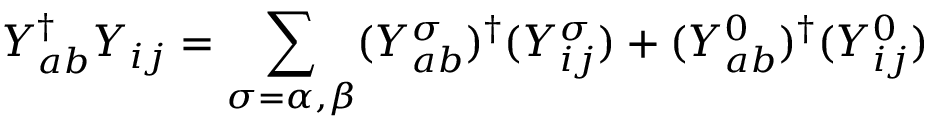Convert formula to latex. <formula><loc_0><loc_0><loc_500><loc_500>Y _ { a b } ^ { \dagger } Y _ { i j } = \sum _ { \sigma = \alpha , \beta } ( Y _ { a b } ^ { \sigma } ) ^ { \dagger } ( Y _ { i j } ^ { \sigma } ) + ( Y _ { a b } ^ { 0 } ) ^ { \dagger } ( Y _ { i j } ^ { 0 } )</formula> 